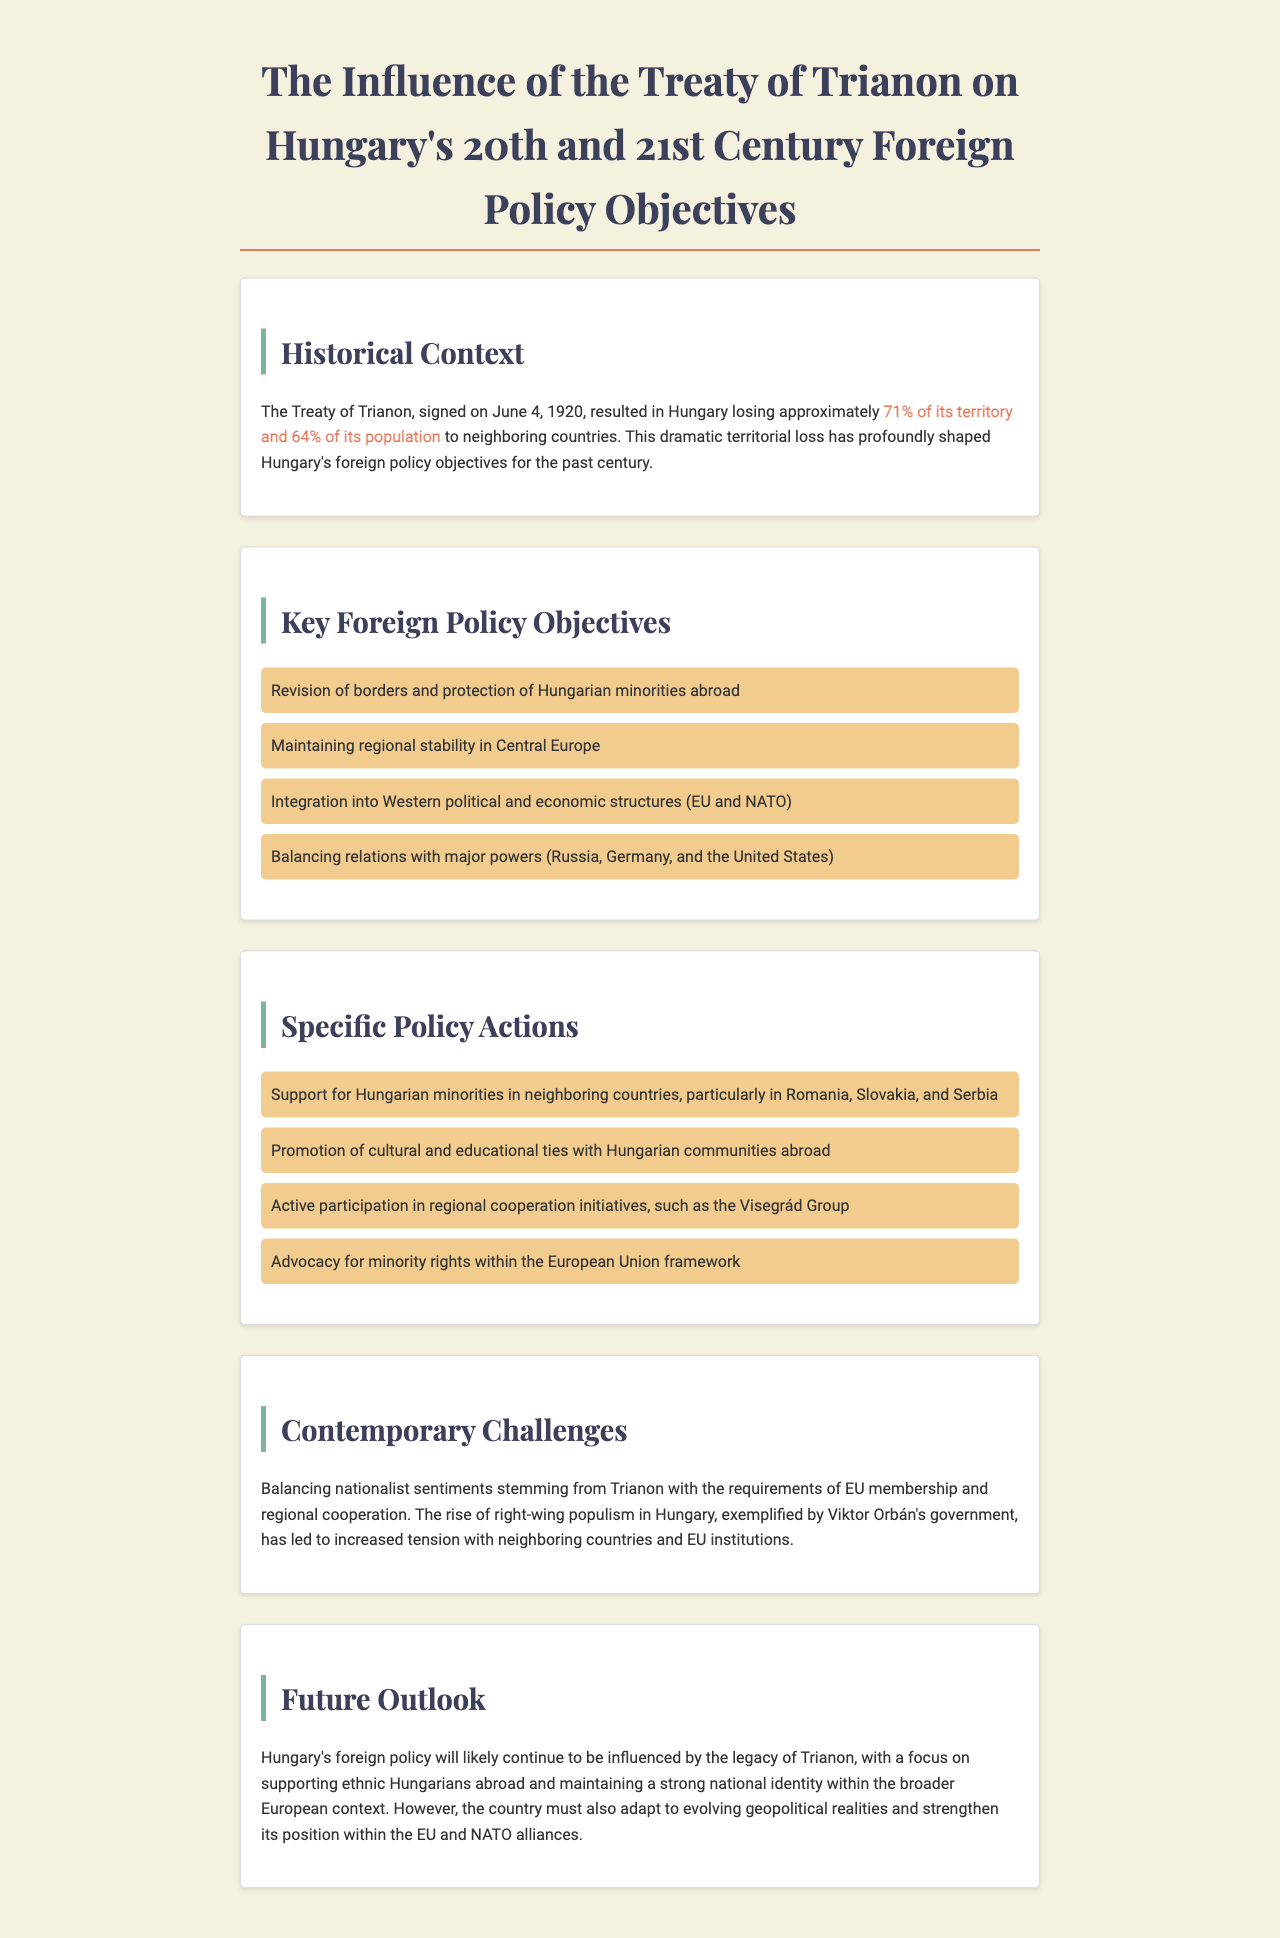What date was the Treaty of Trianon signed? The document states that the Treaty of Trianon was signed on June 4, 1920.
Answer: June 4, 1920 What percentage of territory did Hungary lose due to the Treaty of Trianon? The document mentions that Hungary lost approximately 71% of its territory.
Answer: 71% What is one of Hungary's key foreign policy objectives? The document lists several objectives, one of which is the revision of borders and protection of Hungarian minorities abroad.
Answer: Revision of borders Which group does Hungary actively participate in for regional cooperation? The document emphasizes Hungary's active participation in the Visegrád Group as a regional cooperation initiative.
Answer: Visegrád Group What contemporary challenge does Hungary face regarding Trianon? The document identifies balancing nationalist sentiments stemming from Trianon with the requirements of EU membership as a contemporary challenge.
Answer: Balancing nationalist sentiments What type of rights does Hungary advocate for within the EU framework? The document states that Hungary advocates for minority rights within the European Union framework.
Answer: Minority rights 